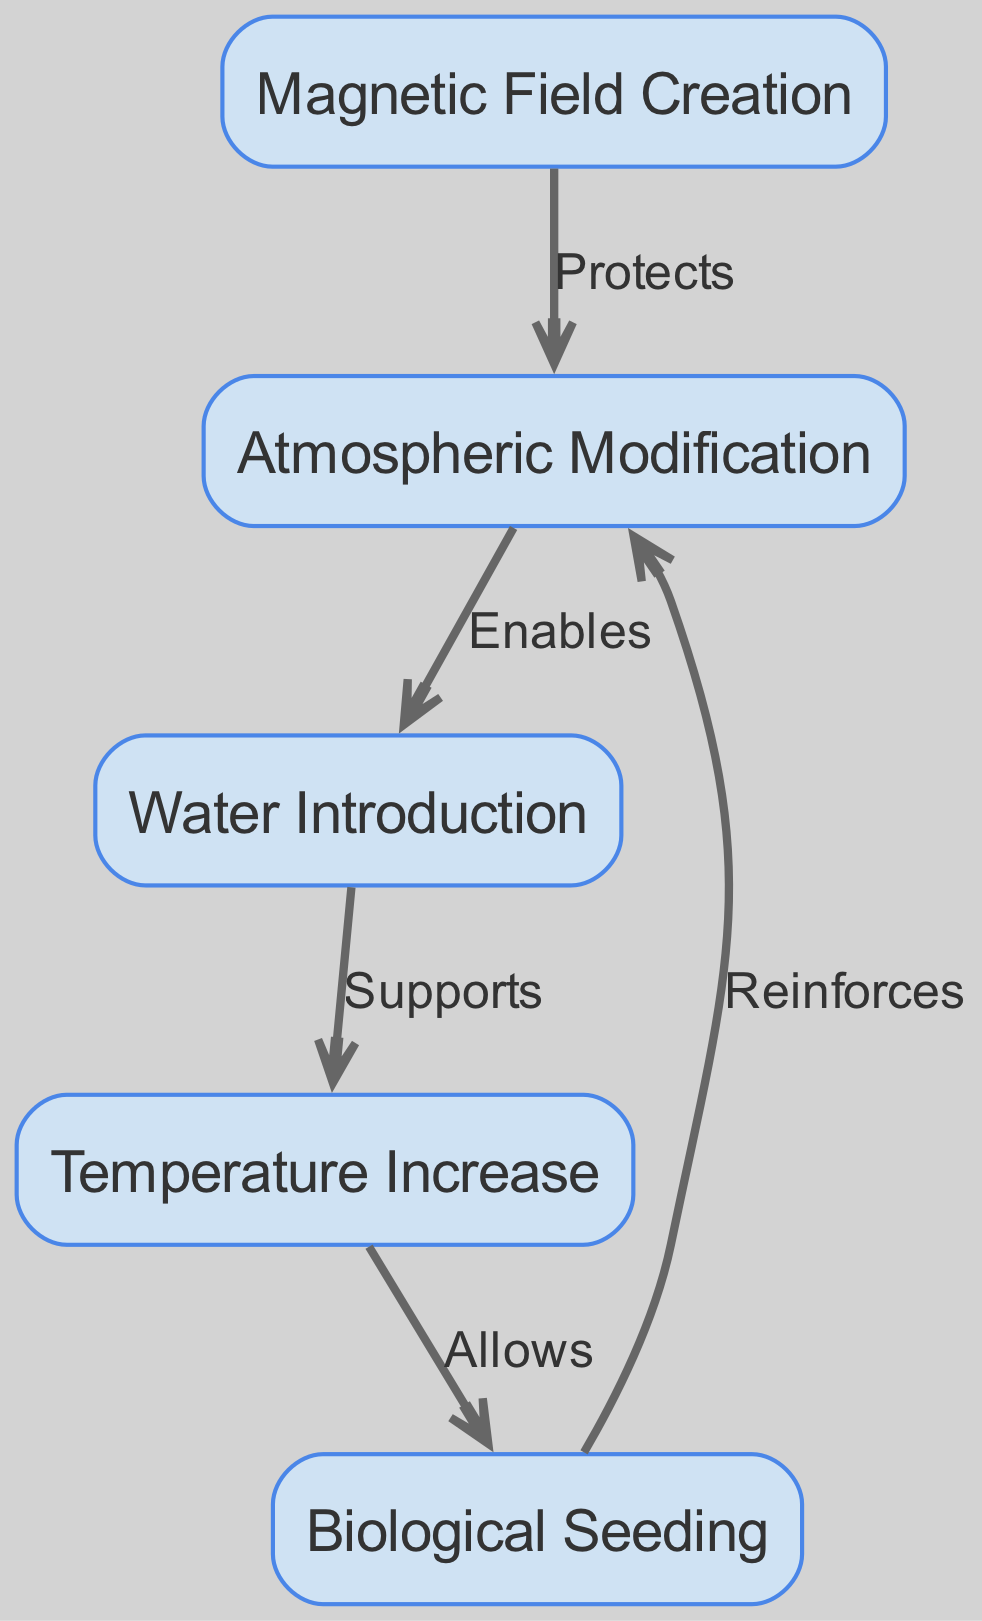What is the label of the node with ID 1? The node with ID 1 is labeled "Atmospheric Modification" as indicated in the nodes section of the data.
Answer: Atmospheric Modification How many nodes are there in the diagram? By counting the entries in the "nodes" list, it is clear that there are five distinct nodes present in the diagram.
Answer: 5 Which node does "Water Introduction" enable? "Water Introduction" is represented by node 2, which has an edge pointing to "Atmospheric Modification" indicating that it enables this process.
Answer: Atmospheric Modification What relationship does "Temperature Increase" have with "Biological Seeding"? "Temperature Increase," labeled as node 3, has a direct edge to "Biological Seeding," indicating it allows the process to occur.
Answer: Allows What is the protective function of "Magnetic Field Creation"? The diagram shows that "Magnetic Field Creation," node 4, has an edge that protects "Atmospheric Modification," which means it plays a protective role regarding that process.
Answer: Protects Which node has the relationship "Reinforces"? The relationship "Reinforces" is between "Biological Seeding" (node 5) and "Atmospheric Modification" (node 1), illustrating how biological seeding can enhance atmospheric modification.
Answer: Reinforces What supports the relationship from "Water Introduction" to "Temperature Increase"? The diagram indicates that "Water Introduction" (node 2) supports the process of "Temperature Increase" (node 3) through a directed edge.
Answer: Supports Summarize the connections based on the edges originating from node 1. The edges originating from node 1, "Atmospheric Modification," are "Enables" to node 2 and "Reinforces" from node 5. This shows its dual role in enabling water introduction and being reinforced by biological seeding.
Answer: Enables and Reinforces What does the flow from "Temperature Increase" lead to? The flow from "Temperature Increase" (node 3) directs to "Biological Seeding" (node 5) indicating that an increase in temperature allows for the introduction of biological agents.
Answer: Biological Seeding 